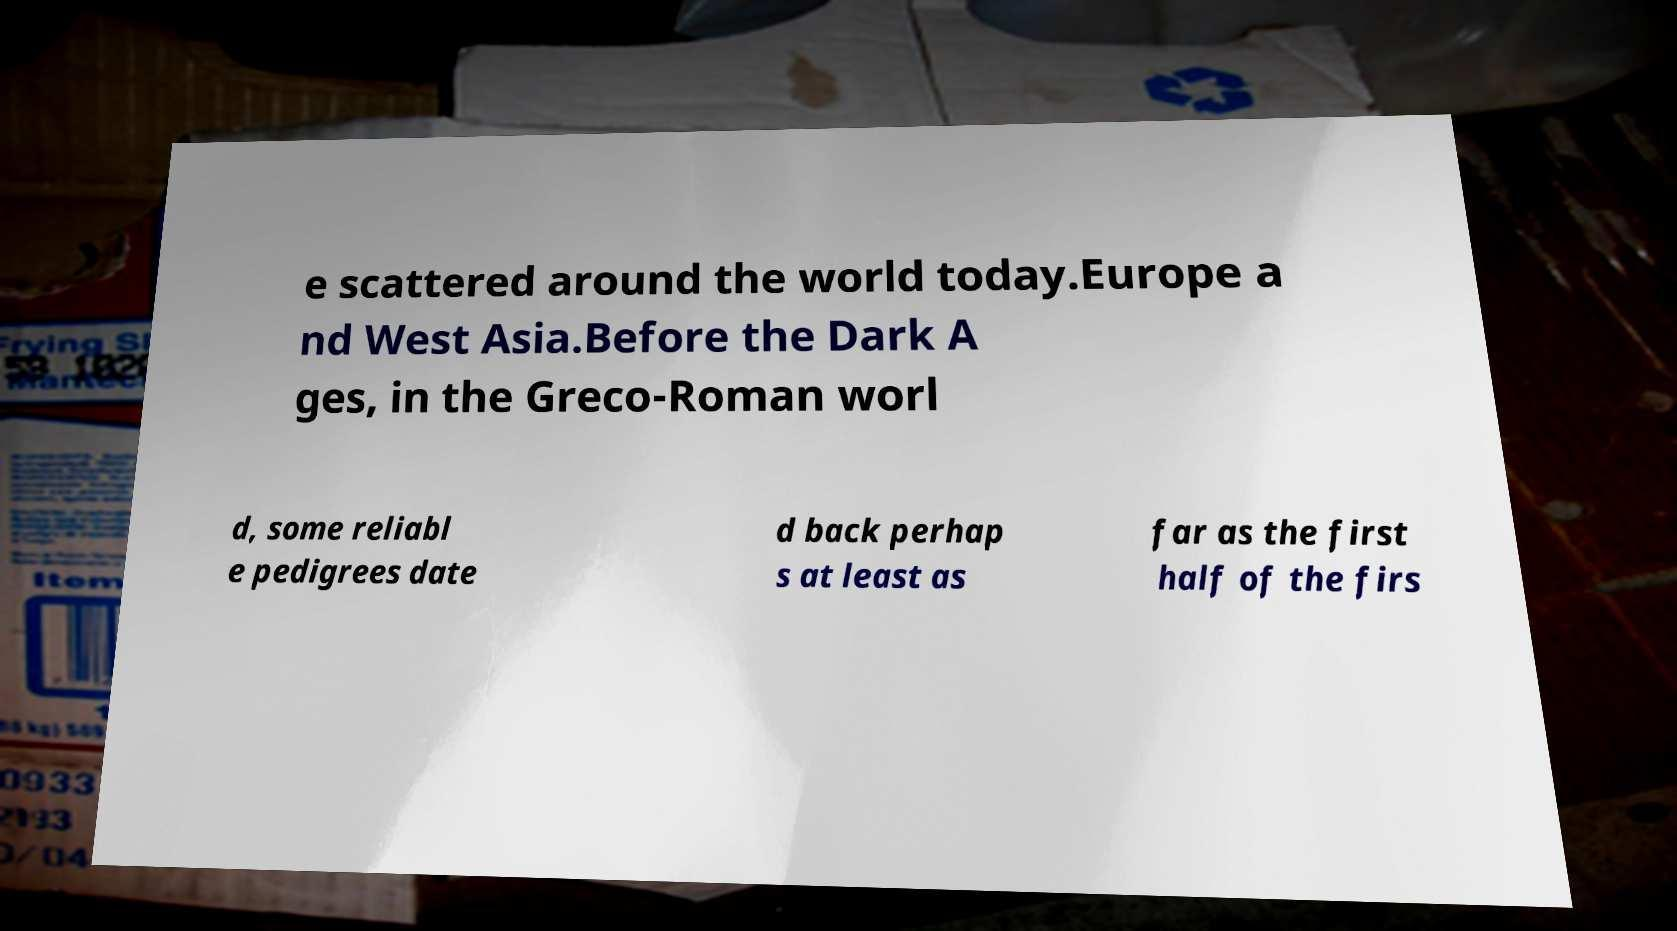Could you extract and type out the text from this image? e scattered around the world today.Europe a nd West Asia.Before the Dark A ges, in the Greco-Roman worl d, some reliabl e pedigrees date d back perhap s at least as far as the first half of the firs 